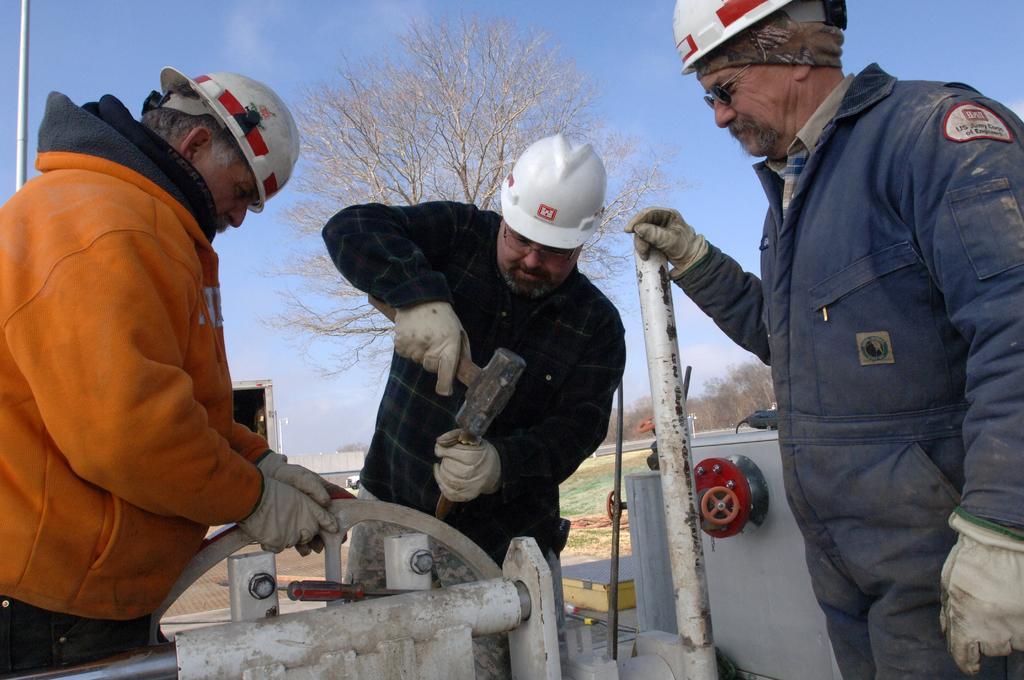Could you give a brief overview of what you see in this image? In this picture there are three men standing and wore helmets and gloves, among them there is a man holding a tool and carving and we can see tools, machine, rod, poles and few objects. In the background of the image we can see trees, road and sky. 